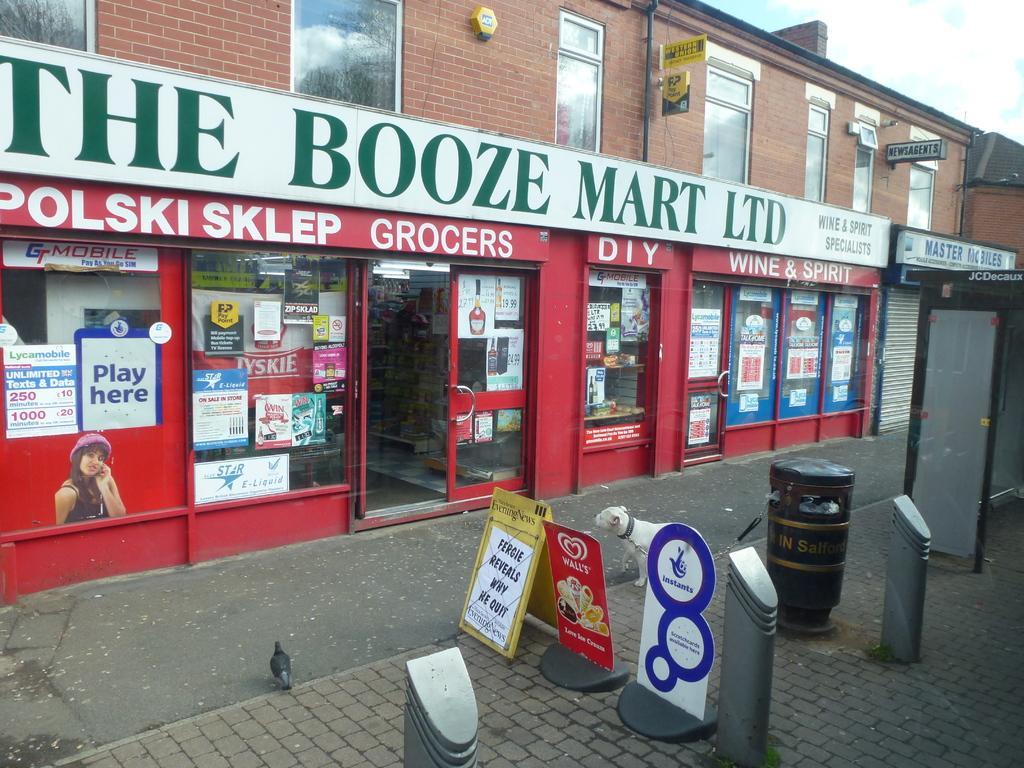Describe this image in one or two sentences. In this image we can see a building, which has a store in it, there is some text on it and there are poster with text on its walls, in front of it there is a dog, a bird, a dustbin, posters and a few other objects. 